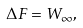Convert formula to latex. <formula><loc_0><loc_0><loc_500><loc_500>\Delta F = W _ { \infty } ,</formula> 